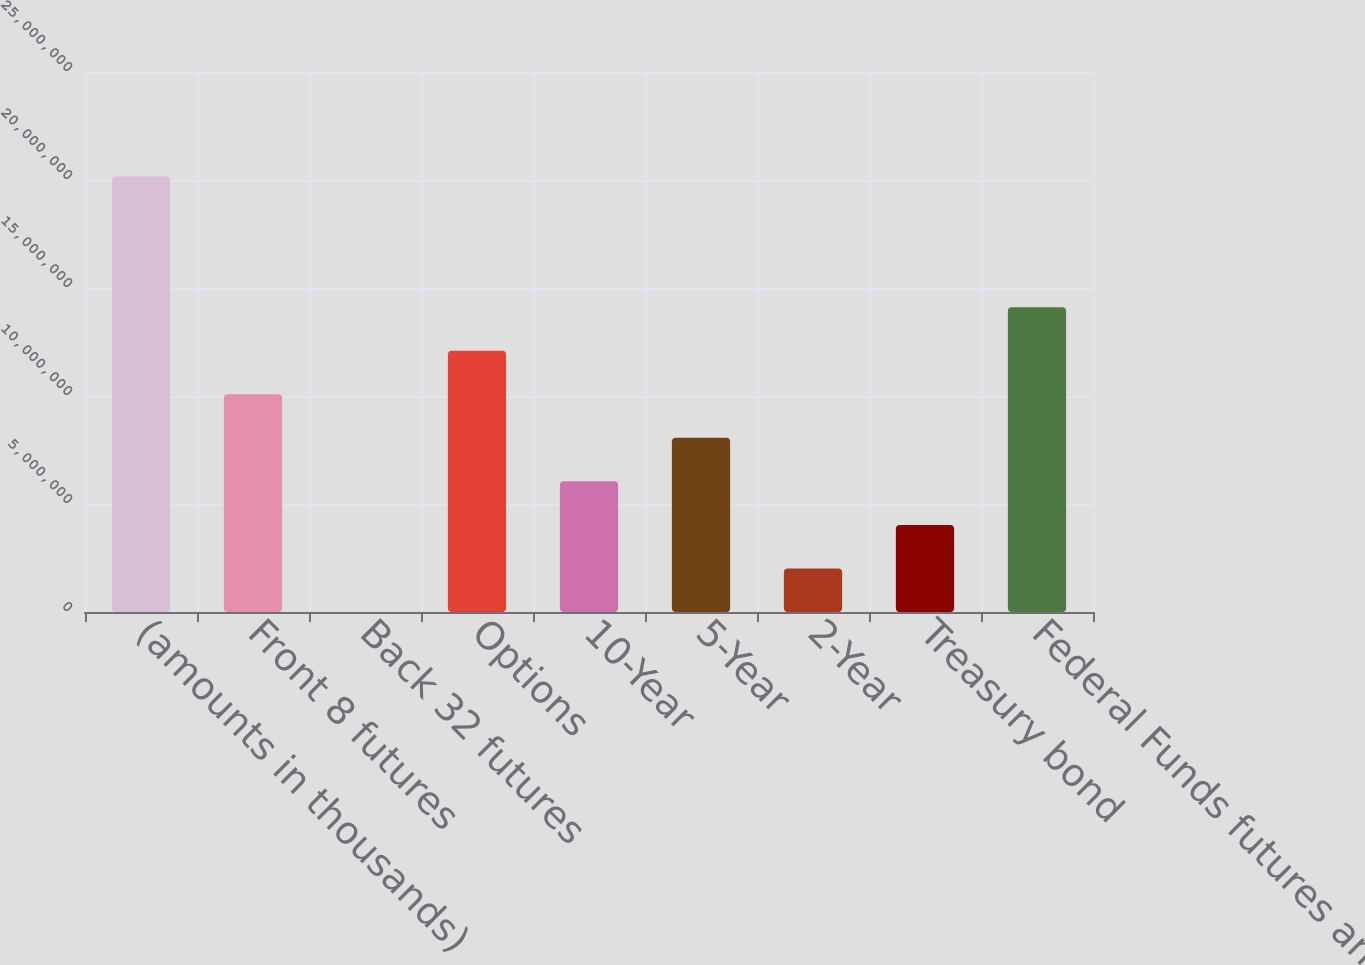<chart> <loc_0><loc_0><loc_500><loc_500><bar_chart><fcel>(amounts in thousands)<fcel>Front 8 futures<fcel>Back 32 futures<fcel>Options<fcel>10-Year<fcel>5-Year<fcel>2-Year<fcel>Treasury bond<fcel>Federal Funds futures and<nl><fcel>2.0162e+07<fcel>1.0081e+07<fcel>1<fcel>1.20972e+07<fcel>6.04861e+06<fcel>8.06481e+06<fcel>2.0162e+06<fcel>4.0324e+06<fcel>1.41134e+07<nl></chart> 